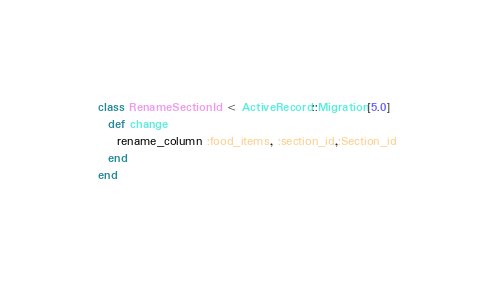<code> <loc_0><loc_0><loc_500><loc_500><_Ruby_>class RenameSectionId < ActiveRecord::Migration[5.0]
  def change
    rename_column :food_items, :section_id,:Section_id
  end
end
</code> 